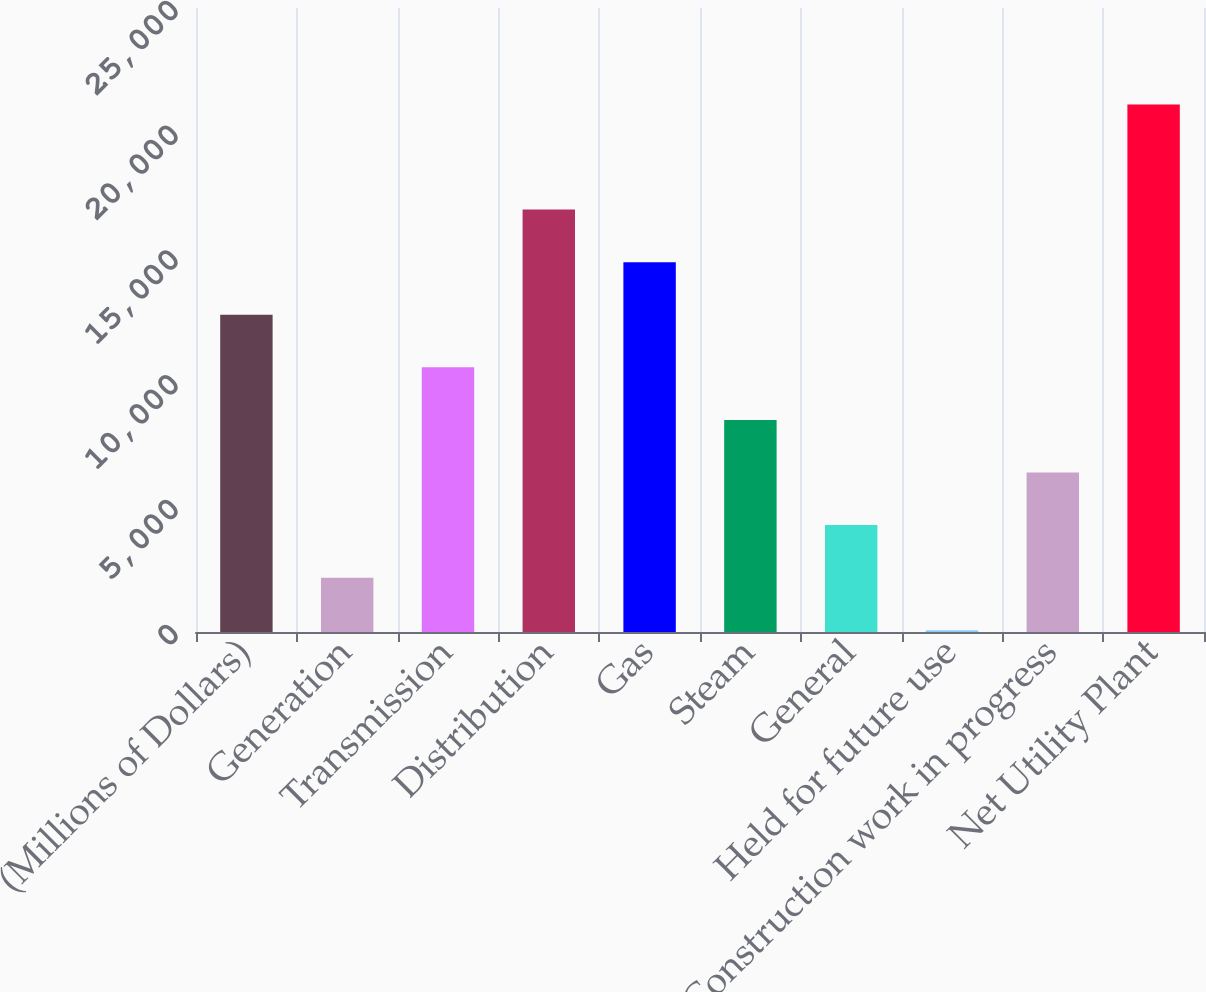Convert chart to OTSL. <chart><loc_0><loc_0><loc_500><loc_500><bar_chart><fcel>(Millions of Dollars)<fcel>Generation<fcel>Transmission<fcel>Distribution<fcel>Gas<fcel>Steam<fcel>General<fcel>Held for future use<fcel>Construction work in progress<fcel>Net Utility Plant<nl><fcel>12710.2<fcel>2176.7<fcel>10603.5<fcel>16923.6<fcel>14816.9<fcel>8496.8<fcel>4283.4<fcel>70<fcel>6390.1<fcel>21137<nl></chart> 